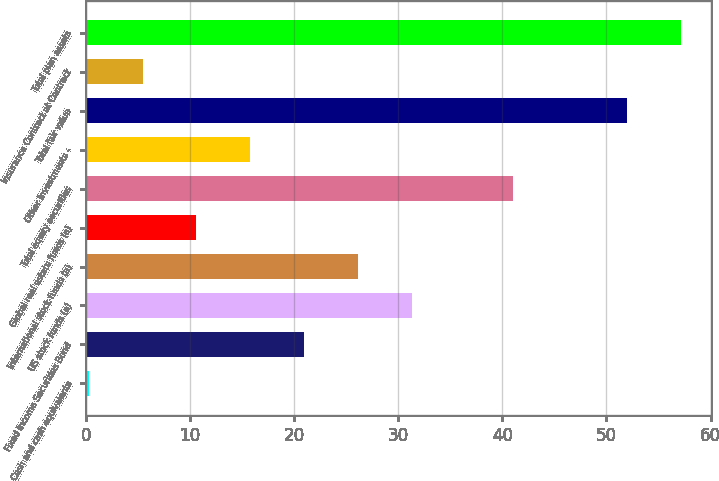Convert chart to OTSL. <chart><loc_0><loc_0><loc_500><loc_500><bar_chart><fcel>Cash and cash equivalents<fcel>Fixed Income Securities Bond<fcel>US stock funds (a)<fcel>International stock funds (a)<fcel>Global real estate funds (a)<fcel>Total equity securities<fcel>Other Investments -<fcel>Total fair value<fcel>Insurance Contract at Contract<fcel>Total plan assets<nl><fcel>0.28<fcel>20.96<fcel>31.3<fcel>26.13<fcel>10.62<fcel>41<fcel>15.79<fcel>52<fcel>5.45<fcel>57.17<nl></chart> 